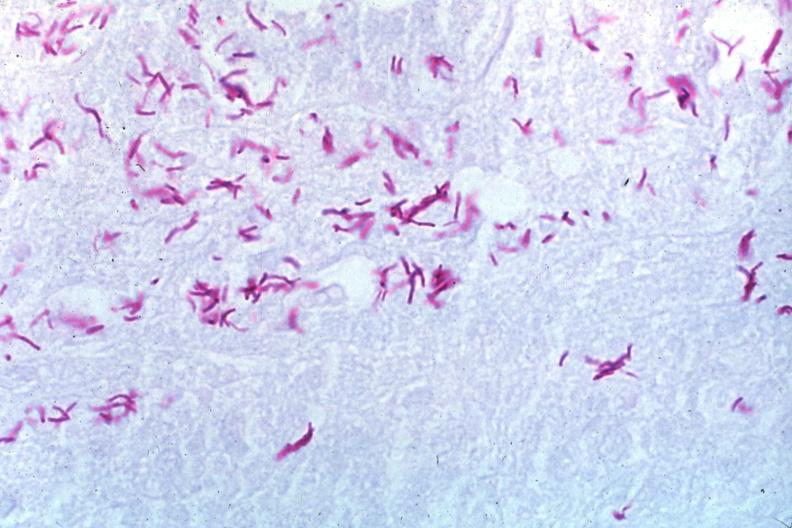what stain a zillion organisms?
Answer the question using a single word or phrase. Oil acid 